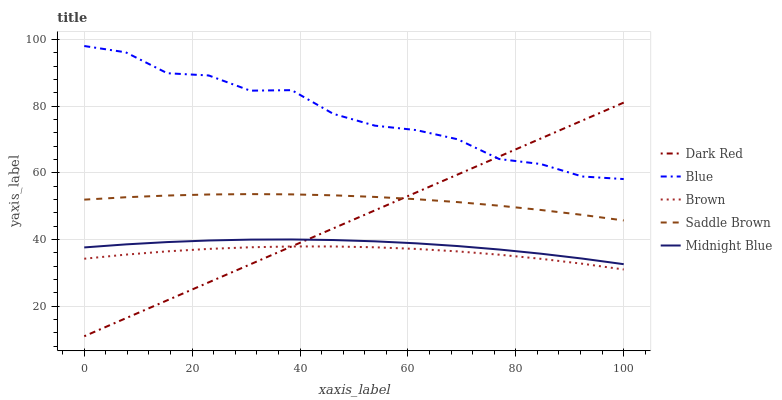Does Brown have the minimum area under the curve?
Answer yes or no. Yes. Does Blue have the maximum area under the curve?
Answer yes or no. Yes. Does Dark Red have the minimum area under the curve?
Answer yes or no. No. Does Dark Red have the maximum area under the curve?
Answer yes or no. No. Is Dark Red the smoothest?
Answer yes or no. Yes. Is Blue the roughest?
Answer yes or no. Yes. Is Midnight Blue the smoothest?
Answer yes or no. No. Is Midnight Blue the roughest?
Answer yes or no. No. Does Midnight Blue have the lowest value?
Answer yes or no. No. Does Blue have the highest value?
Answer yes or no. Yes. Does Dark Red have the highest value?
Answer yes or no. No. Is Brown less than Midnight Blue?
Answer yes or no. Yes. Is Blue greater than Brown?
Answer yes or no. Yes. Does Midnight Blue intersect Dark Red?
Answer yes or no. Yes. Is Midnight Blue less than Dark Red?
Answer yes or no. No. Is Midnight Blue greater than Dark Red?
Answer yes or no. No. Does Brown intersect Midnight Blue?
Answer yes or no. No. 